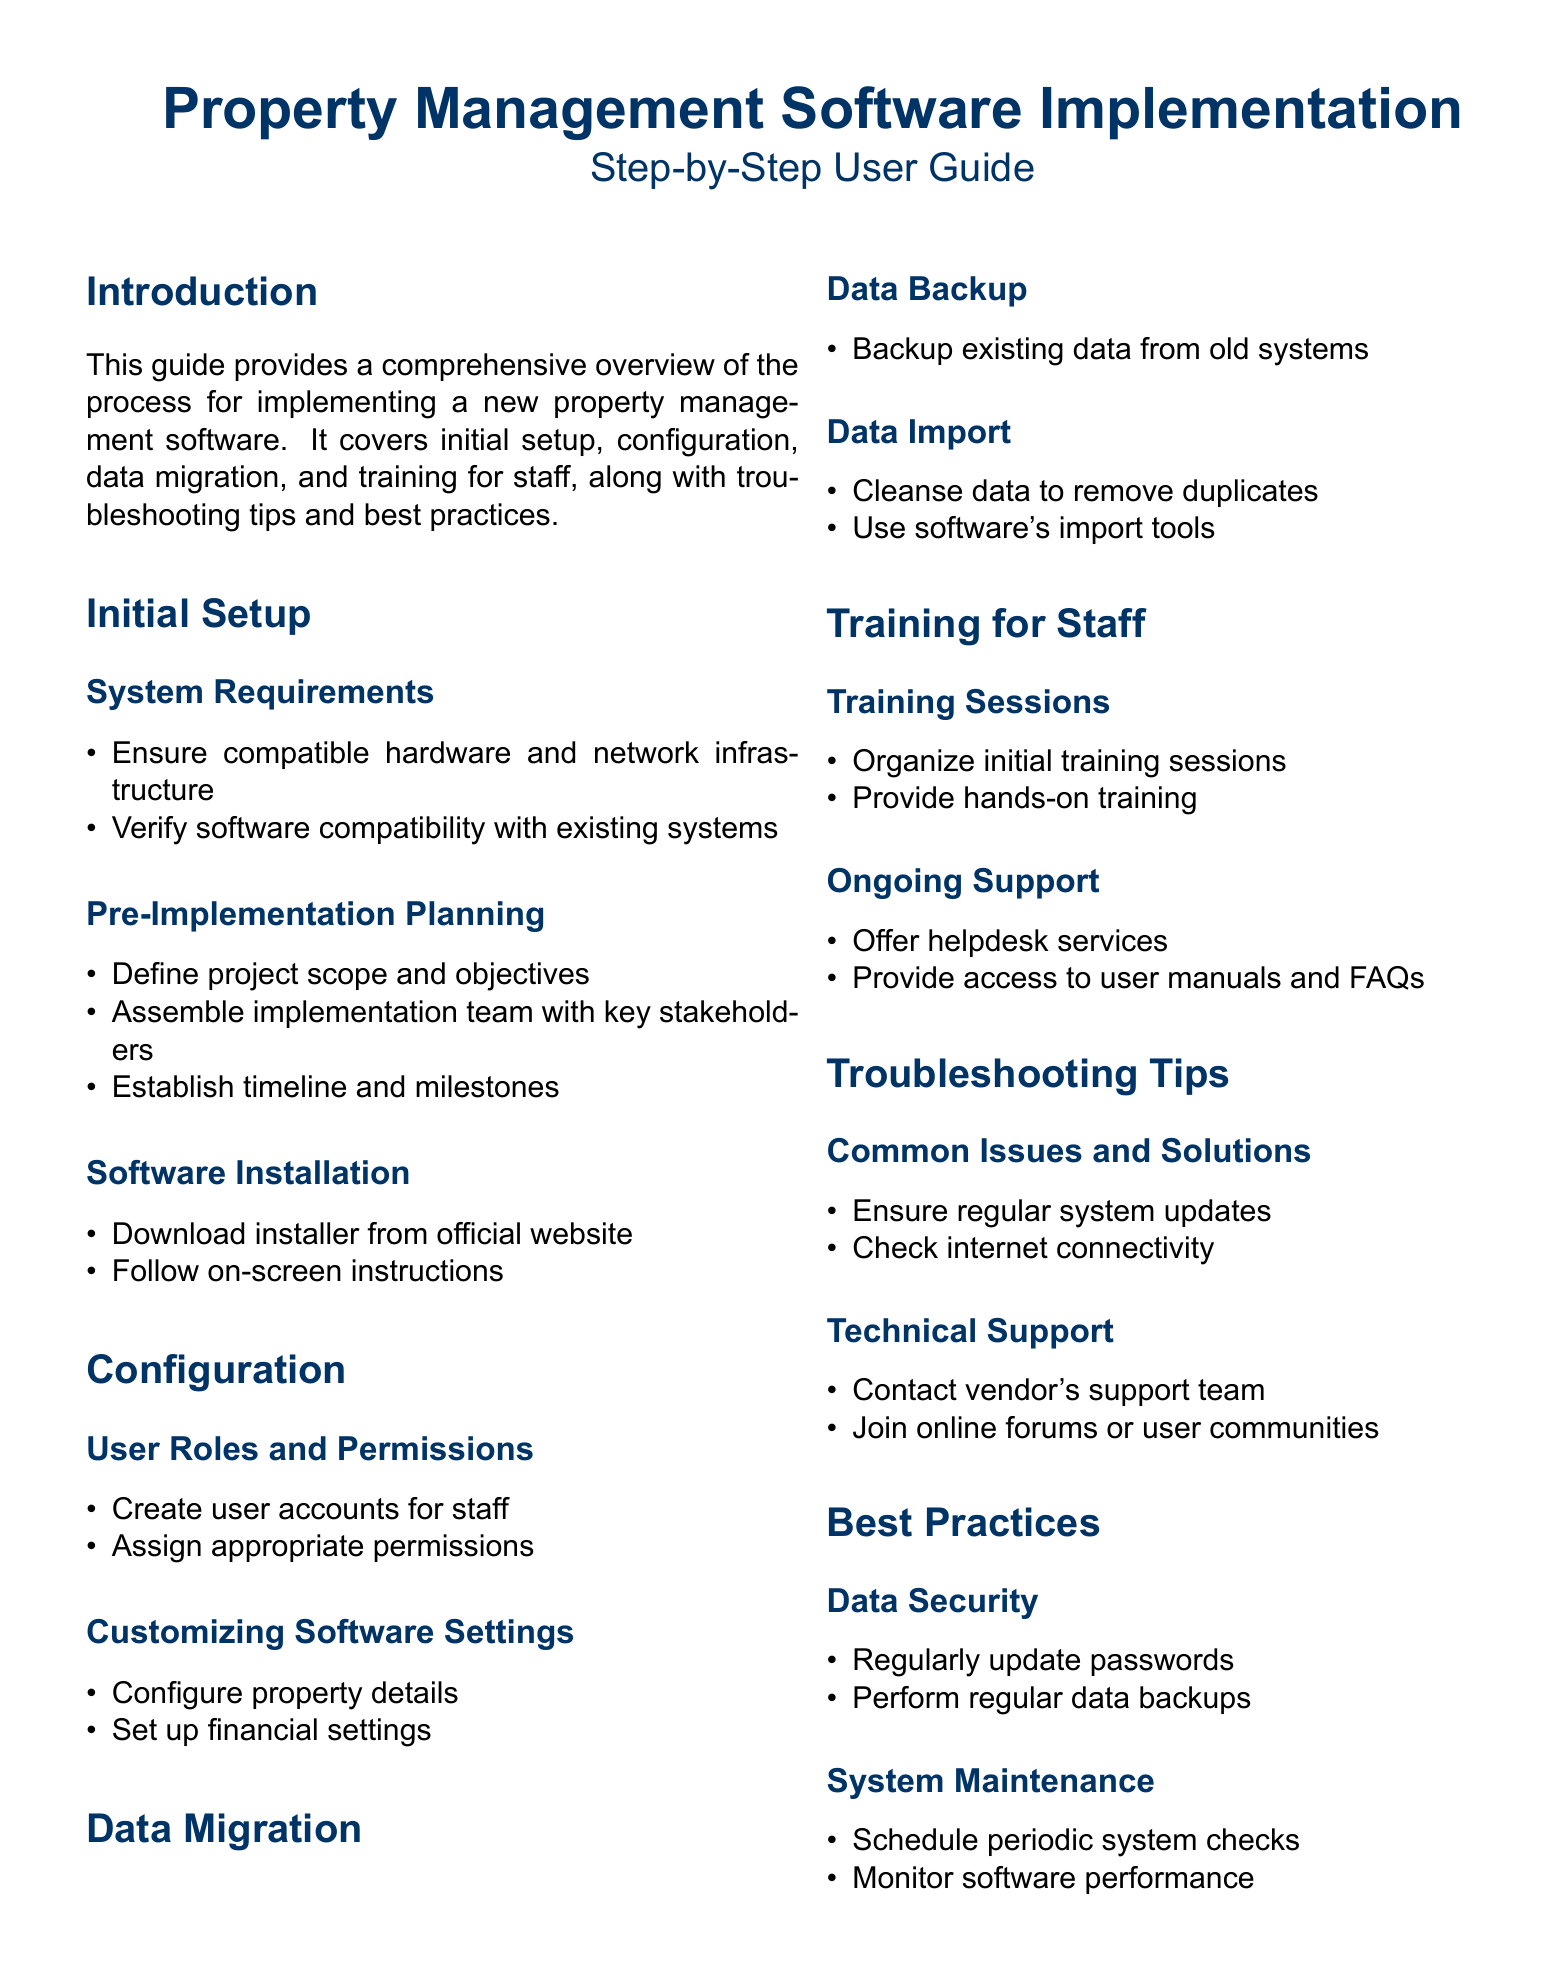What is the focus of this guide? The guide provides a comprehensive overview of the process for implementing a new property management software.
Answer: Implementing a new property management software How many main sections are in the document? The document contains several sections, namely Introduction, Initial Setup, Configuration, Data Migration, Training for Staff, Troubleshooting Tips, and Best Practices.
Answer: Seven What is the first step in the Initial Setup? The first step in the Initial Setup is to ensure compatible hardware and network infrastructure.
Answer: Ensure compatible hardware and network infrastructure What is recommended to do with existing data before migration? It is recommended to backup existing data from old systems before migration.
Answer: Backup existing data from old systems Which team is suggested to be assembled for pre-implementation planning? The document suggests assembling an implementation team with key stakeholders.
Answer: Implementation team with key stakeholders What should you do if you encounter common issues? You should ensure regular system updates and check internet connectivity if you encounter common issues.
Answer: Ensure regular system updates What type of training is organized for staff? The document states that initial training sessions are organized for staff.
Answer: Initial training sessions What should you do to maintain data security? Regularly updating passwords is suggested to maintain data security.
Answer: Regularly update passwords Which community resource can help with technical support? Joining online forums or user communities can help with technical support.
Answer: Online forums or user communities 